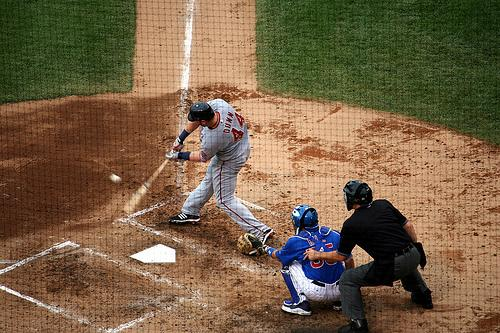Highlight the main subject in the image and their objective in a succinct manner. The image depicts a baseball player focused on hitting the ball in the air, amplifying the intensity and thrill of the game. Comment on the central character in the image and their attire as though you're giving fashion advice. The focal point of the image is a baseball player, rocking a stylish black helmet and a modern gray uniform while expertly wielding a wooden bat. Sum up the image's content focusing on the attire and equipment of the people in it. Multiple men wear black suits, face masks, helmets, and gloves as they hold baseball bats and engage in a baseball game with white plates on the ground. What is the main theme of this image, and how are the people involved dressed? The main theme is baseball, with players dressed in black suits, catcher and umpire wearing face masks, and a batter in a black helmet and gray uniform. Write down the key elements of the image and their interrelations in a casual way. A guy's trying to hit a ball in the air with his bat, while others wear face masks and black suits, and there are white plates all over the place. Provide a brief description of the primary action taking place in the image. A man is playing baseball, wearing a black helmet and gray uniform, holding a bat and swinging it as the ball is in the air. Illustrate the core action in the image using analogies or metaphors. Like a fierce warrior, the baseball player stands ready for battle, gracefully swinging his wooden weapon towards destiny's spherical challenge. Express the main activity happening in the image and the emotions it conveys. The intense moment of a baseball game is captured as a man swings a wooden bat at a flying ball, showing excitement and anticipation. Narrate the central scene in the image using a poetic tone. In a field where giants clash, the batter donned in black and gray awaits as the sphere of fate dances through the air towards destiny's embrace. Write a newspaper headline summarizing the ongoing activity within the image. "Player Swings for Glory: An Intense Moment Frozen in Time as the Bat Meets Ball in Exciting Baseball Game" 